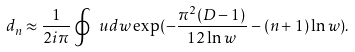Convert formula to latex. <formula><loc_0><loc_0><loc_500><loc_500>d _ { n } \approx \frac { 1 } { 2 i \pi } \oint \ u d w \exp ( - \frac { \pi ^ { 2 } ( D - 1 ) } { 1 2 \ln { w } } - ( n + 1 ) \ln w ) .</formula> 